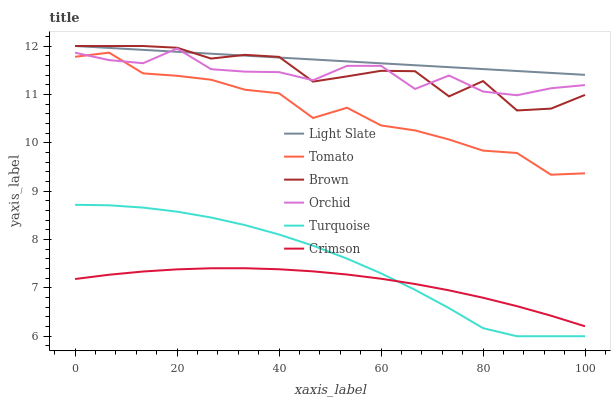Does Crimson have the minimum area under the curve?
Answer yes or no. Yes. Does Light Slate have the maximum area under the curve?
Answer yes or no. Yes. Does Brown have the minimum area under the curve?
Answer yes or no. No. Does Brown have the maximum area under the curve?
Answer yes or no. No. Is Light Slate the smoothest?
Answer yes or no. Yes. Is Brown the roughest?
Answer yes or no. Yes. Is Turquoise the smoothest?
Answer yes or no. No. Is Turquoise the roughest?
Answer yes or no. No. Does Brown have the lowest value?
Answer yes or no. No. Does Light Slate have the highest value?
Answer yes or no. Yes. Does Turquoise have the highest value?
Answer yes or no. No. Is Crimson less than Light Slate?
Answer yes or no. Yes. Is Orchid greater than Turquoise?
Answer yes or no. Yes. Does Orchid intersect Light Slate?
Answer yes or no. Yes. Is Orchid less than Light Slate?
Answer yes or no. No. Is Orchid greater than Light Slate?
Answer yes or no. No. Does Crimson intersect Light Slate?
Answer yes or no. No. 